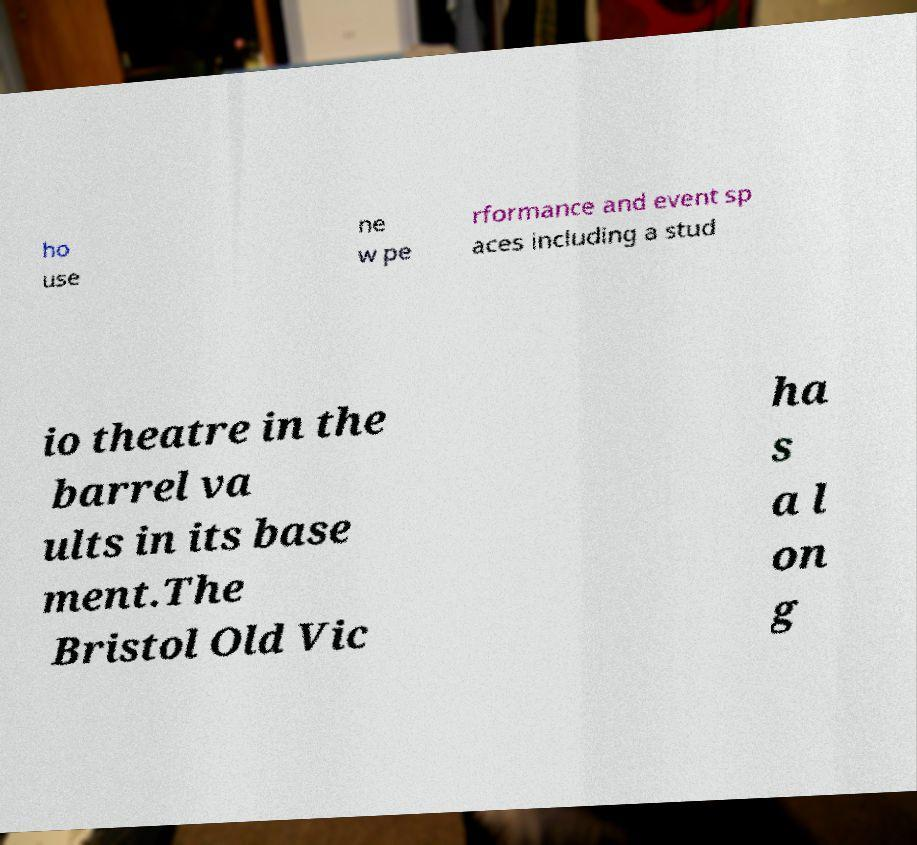Please identify and transcribe the text found in this image. ho use ne w pe rformance and event sp aces including a stud io theatre in the barrel va ults in its base ment.The Bristol Old Vic ha s a l on g 